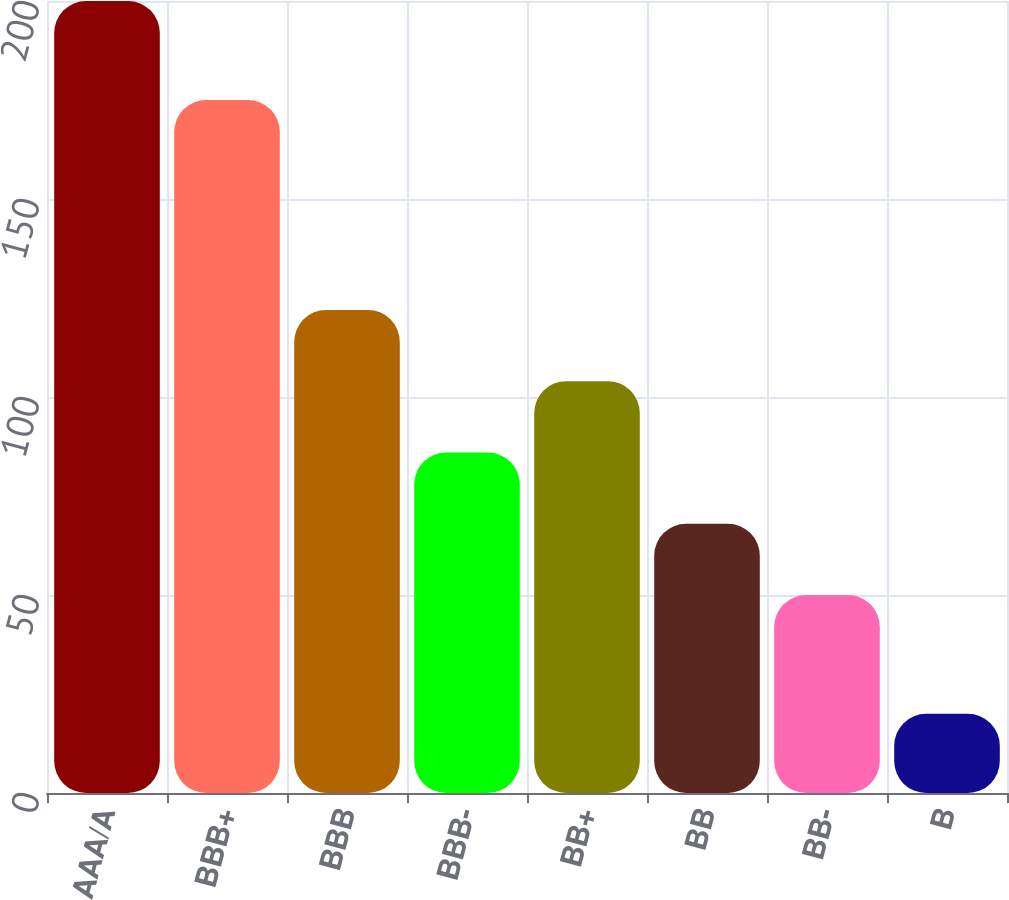<chart> <loc_0><loc_0><loc_500><loc_500><bar_chart><fcel>AAA/A<fcel>BBB+<fcel>BBB<fcel>BBB-<fcel>BB+<fcel>BB<fcel>BB-<fcel>B<nl><fcel>200<fcel>175<fcel>122<fcel>86<fcel>104<fcel>68<fcel>50<fcel>20<nl></chart> 